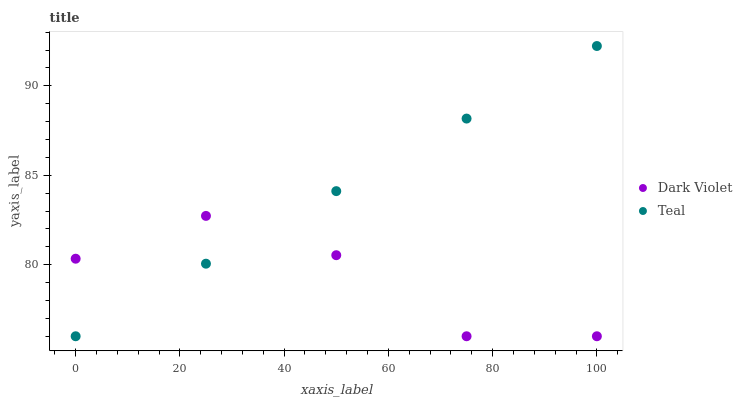Does Dark Violet have the minimum area under the curve?
Answer yes or no. Yes. Does Teal have the maximum area under the curve?
Answer yes or no. Yes. Does Dark Violet have the maximum area under the curve?
Answer yes or no. No. Is Teal the smoothest?
Answer yes or no. Yes. Is Dark Violet the roughest?
Answer yes or no. Yes. Is Dark Violet the smoothest?
Answer yes or no. No. Does Teal have the lowest value?
Answer yes or no. Yes. Does Teal have the highest value?
Answer yes or no. Yes. Does Dark Violet have the highest value?
Answer yes or no. No. Does Teal intersect Dark Violet?
Answer yes or no. Yes. Is Teal less than Dark Violet?
Answer yes or no. No. Is Teal greater than Dark Violet?
Answer yes or no. No. 